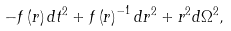Convert formula to latex. <formula><loc_0><loc_0><loc_500><loc_500>- f \left ( r \right ) d t ^ { 2 } + f \left ( r \right ) ^ { - 1 } d r ^ { 2 } + r ^ { 2 } d \Omega ^ { 2 } ,</formula> 